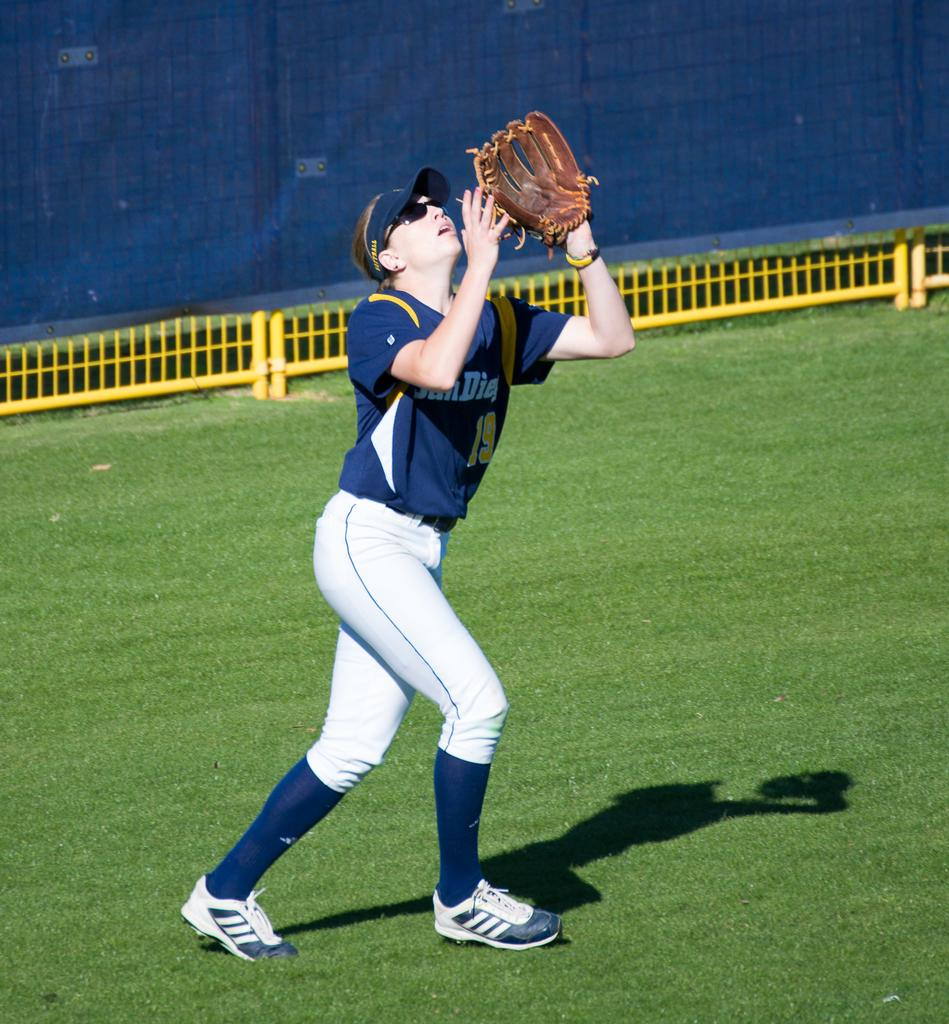Provide a one-sentence caption for the provided image. Female baseball player number nineteen that is playing for San Diego. 